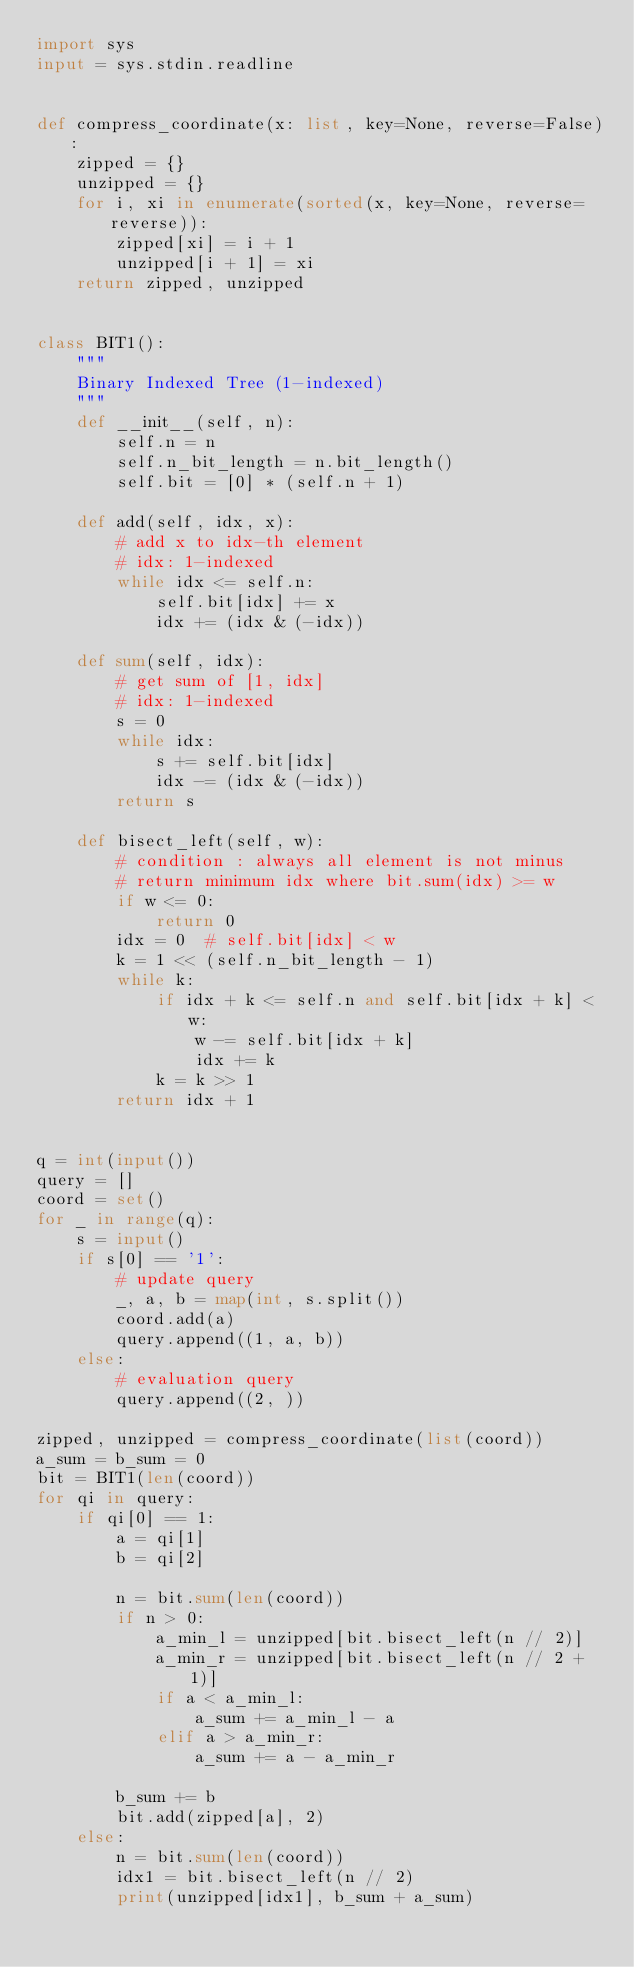Convert code to text. <code><loc_0><loc_0><loc_500><loc_500><_Python_>import sys
input = sys.stdin.readline


def compress_coordinate(x: list, key=None, reverse=False):
    zipped = {}
    unzipped = {}
    for i, xi in enumerate(sorted(x, key=None, reverse=reverse)):
        zipped[xi] = i + 1
        unzipped[i + 1] = xi
    return zipped, unzipped


class BIT1():
    """
    Binary Indexed Tree (1-indexed)
    """
    def __init__(self, n):
        self.n = n
        self.n_bit_length = n.bit_length()
        self.bit = [0] * (self.n + 1)

    def add(self, idx, x):
        # add x to idx-th element
        # idx: 1-indexed
        while idx <= self.n:
            self.bit[idx] += x
            idx += (idx & (-idx))

    def sum(self, idx):
        # get sum of [1, idx]
        # idx: 1-indexed
        s = 0
        while idx:
            s += self.bit[idx]
            idx -= (idx & (-idx))
        return s

    def bisect_left(self, w):
        # condition : always all element is not minus
        # return minimum idx where bit.sum(idx) >= w
        if w <= 0:
            return 0
        idx = 0  # self.bit[idx] < w
        k = 1 << (self.n_bit_length - 1)
        while k:
            if idx + k <= self.n and self.bit[idx + k] < w:
                w -= self.bit[idx + k]
                idx += k
            k = k >> 1
        return idx + 1


q = int(input())
query = []
coord = set()
for _ in range(q):
    s = input()
    if s[0] == '1':
        # update query
        _, a, b = map(int, s.split())
        coord.add(a)
        query.append((1, a, b))
    else:
        # evaluation query
        query.append((2, ))

zipped, unzipped = compress_coordinate(list(coord))
a_sum = b_sum = 0
bit = BIT1(len(coord))
for qi in query:
    if qi[0] == 1:
        a = qi[1]
        b = qi[2]

        n = bit.sum(len(coord))
        if n > 0:
            a_min_l = unzipped[bit.bisect_left(n // 2)]
            a_min_r = unzipped[bit.bisect_left(n // 2 + 1)]
            if a < a_min_l:
                a_sum += a_min_l - a
            elif a > a_min_r:
                a_sum += a - a_min_r

        b_sum += b
        bit.add(zipped[a], 2)
    else:
        n = bit.sum(len(coord))
        idx1 = bit.bisect_left(n // 2)
        print(unzipped[idx1], b_sum + a_sum)
</code> 